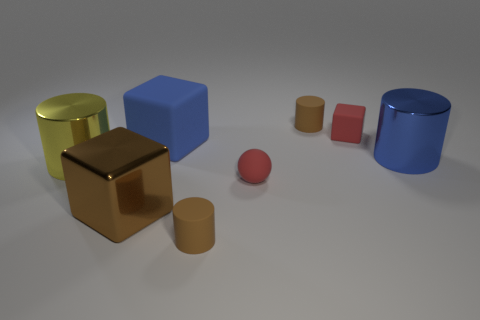What can you tell about the different textures present in the image? The image showcases a variety of textures: the matte textured surfaces of the cylinders and tiny cube do not reflect much light, while the larger cube and the two objects on the right have smooth, reflective surfaces that mirror their environment and bounce light back at the viewer. 